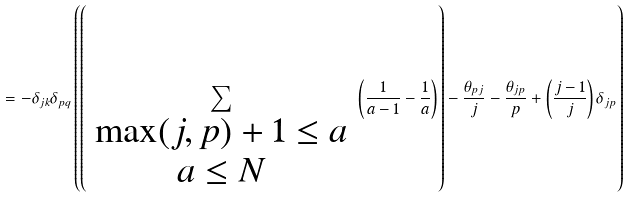Convert formula to latex. <formula><loc_0><loc_0><loc_500><loc_500>= - \delta _ { j k } \delta _ { p q } \left ( \left ( \sum _ { \begin{array} { c } \max ( j , p ) + 1 \leq a \\ a \leq N \end{array} } \left ( \frac { 1 } { a - 1 } - \frac { 1 } { a } \right ) \right ) - \frac { \theta _ { p j } } { j } - \frac { \theta _ { j p } } { p } + \left ( \frac { j - 1 } { j } \right ) \delta _ { j p } \right )</formula> 